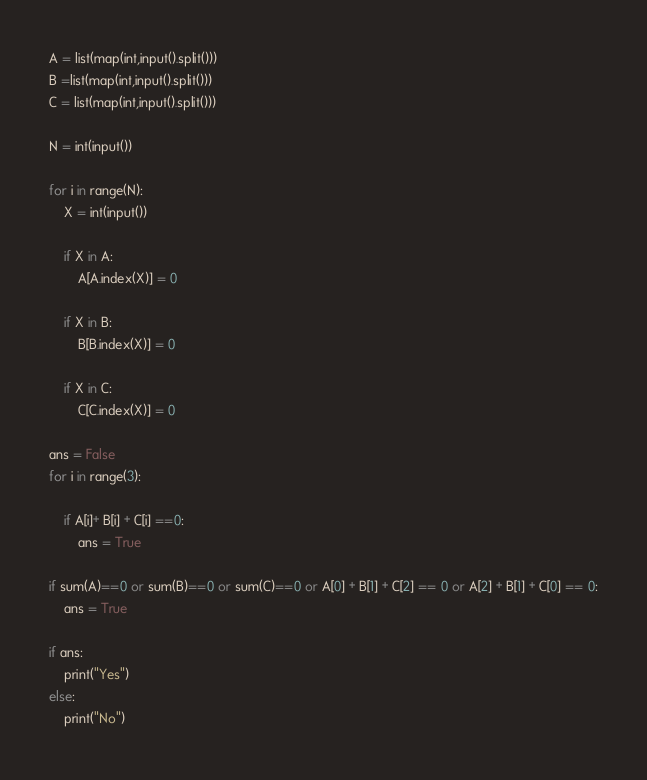Convert code to text. <code><loc_0><loc_0><loc_500><loc_500><_Python_>A = list(map(int,input().split()))
B =list(map(int,input().split()))
C = list(map(int,input().split()))

N = int(input())

for i in range(N):
    X = int(input())
    
    if X in A:
        A[A.index(X)] = 0
    
    if X in B:
        B[B.index(X)] = 0
    
    if X in C:
        C[C.index(X)] = 0
        
ans = False
for i in range(3):
    
    if A[i]+ B[i] + C[i] ==0:
        ans = True
        
if sum(A)==0 or sum(B)==0 or sum(C)==0 or A[0] + B[1] + C[2] == 0 or A[2] + B[1] + C[0] == 0:
    ans = True
    
if ans:
    print("Yes")
else:
    print("No")</code> 